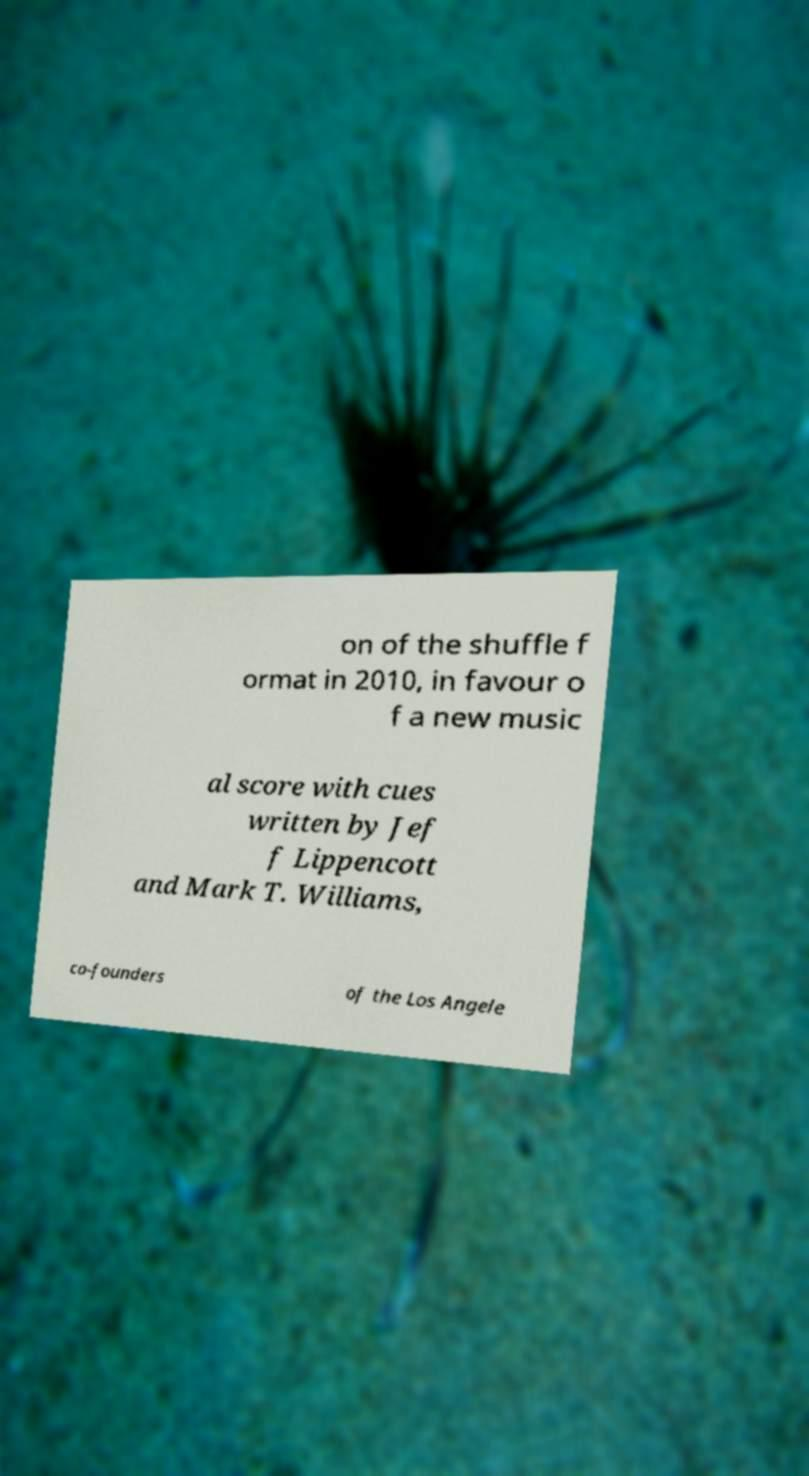I need the written content from this picture converted into text. Can you do that? on of the shuffle f ormat in 2010, in favour o f a new music al score with cues written by Jef f Lippencott and Mark T. Williams, co-founders of the Los Angele 